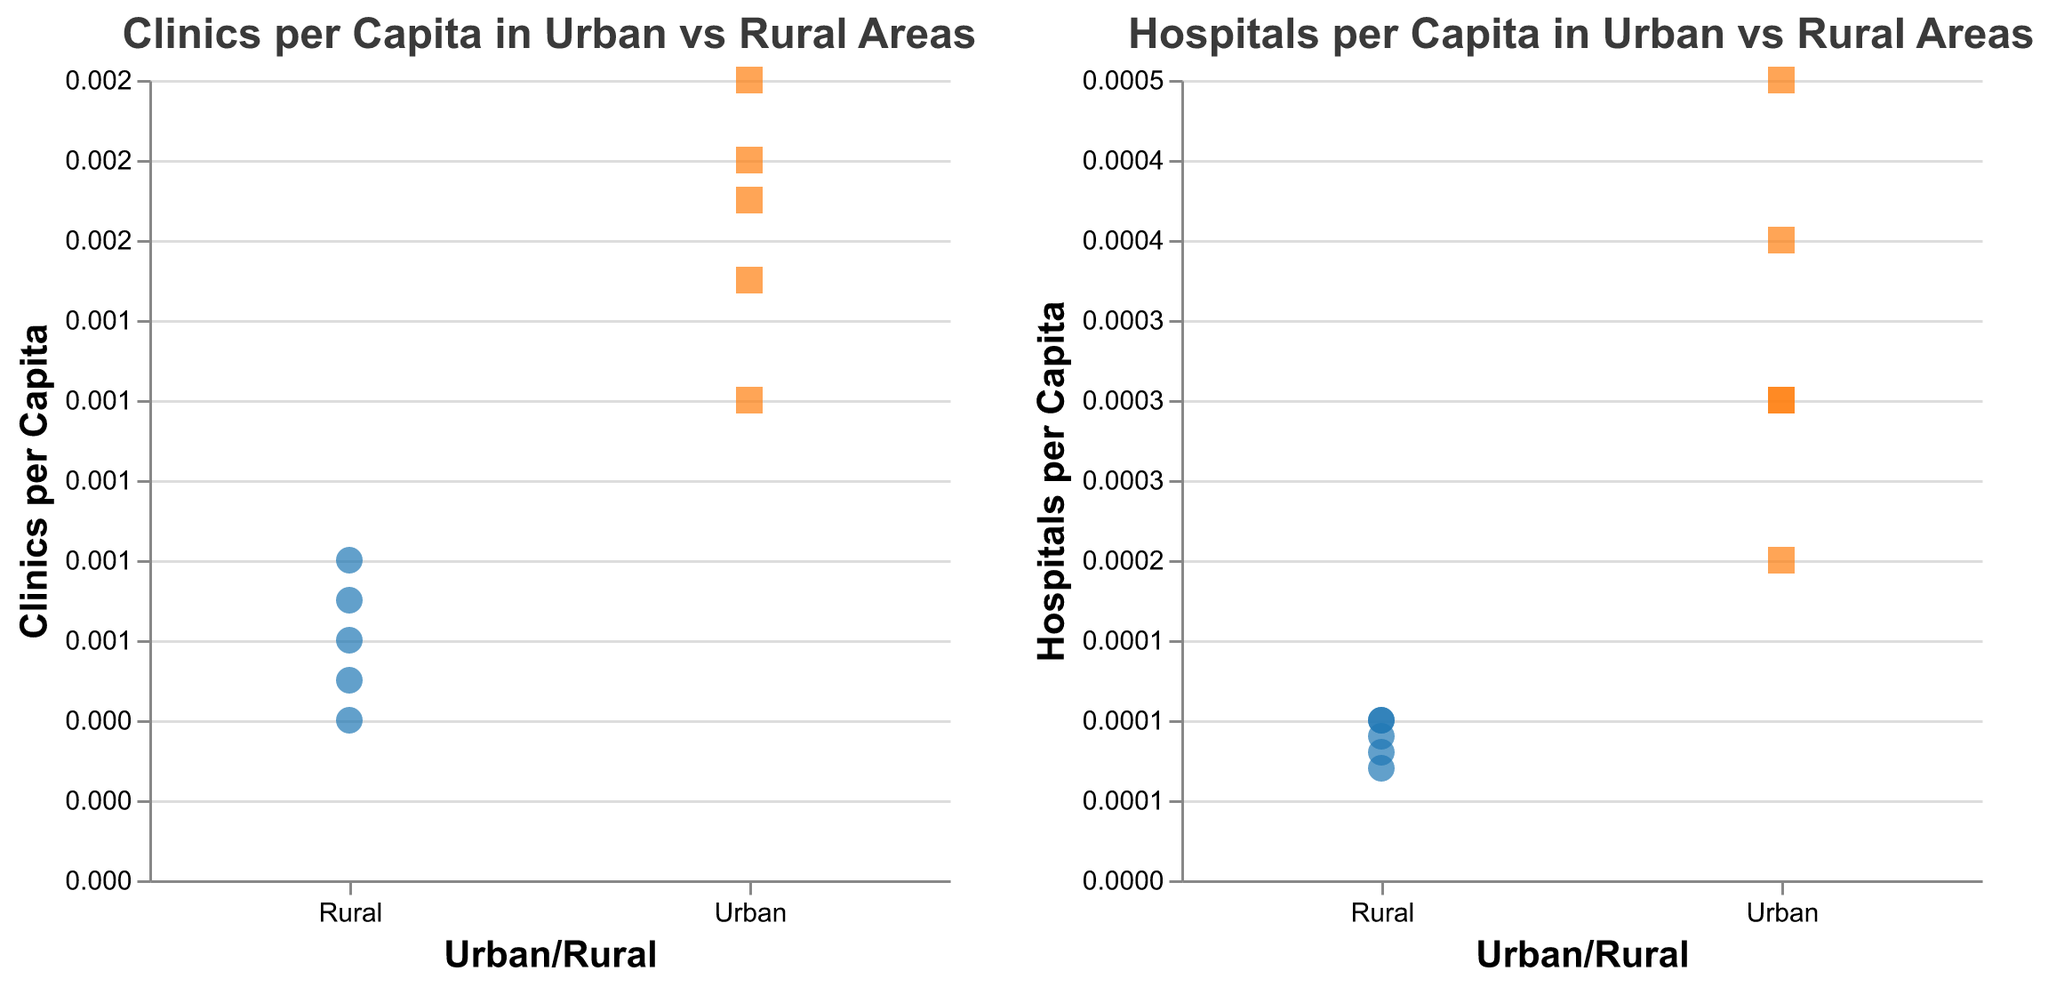Which area has the highest clinics per capita? Examining the "Clinics per Capita in Urban vs Rural Areas" subplot, we observe that Cotonou (an urban area) has the highest value for clinics per capita at 0.002.
Answer: Cotonou Which rural location has the lowest hospitals per capita? Looking at the "Hospitals per Capita in Urban vs Rural Areas" subplot, Matéri has the lowest hospitals per capita value of 0.00007.
Answer: Matéri Is the clinics per capita higher in urban or rural areas? By comparing the data points between the two subplots, it is clear that urban areas generally have higher clinics per capita values than rural areas.
Answer: Urban What is the average clinics per capita in rural areas? Sum the clinics per capita for rural areas (0.0008, 0.0005, 0.0007, 0.0006, 0.0004) and divide by the number of rural locations (5): (0.0008 + 0.0005 + 0.0007 + 0.0006 + 0.0004) / 5 = 0.0006
Answer: 0.0006 Compare the hospitals per capita between Allada and Porto-Novo. Allada (a rural area) has a hospitals per capita value of 0.0001, whereas Porto-Novo (an urban area) has a value of 0.0004. Urban Porto-Novo has a higher hospitals per capita compared to rural Allada.
Answer: Porto-Novo Which urban location has lower clinics per capita than any rural location? Examining the "Clinics per Capita in Urban vs Rural Areas" subplot, there's no urban location that has a lower clinics per capita value than the lowest rural data point of 0.0004 (Matéri).
Answer: None Is there any overlap in the range of hospitals per capita values between urban and rural areas? The highest hospitals per capita value in rural areas is 0.0001, while the lowest in urban areas is 0.0003. There is no overlap in the range of hospitals per capita values between urban and rural areas.
Answer: No How many locations in total are displayed in the visualizations? Counting all the data points in both the urban and rural categories, there are a total of 10 locations shown in the visualizations.
Answer: 10 